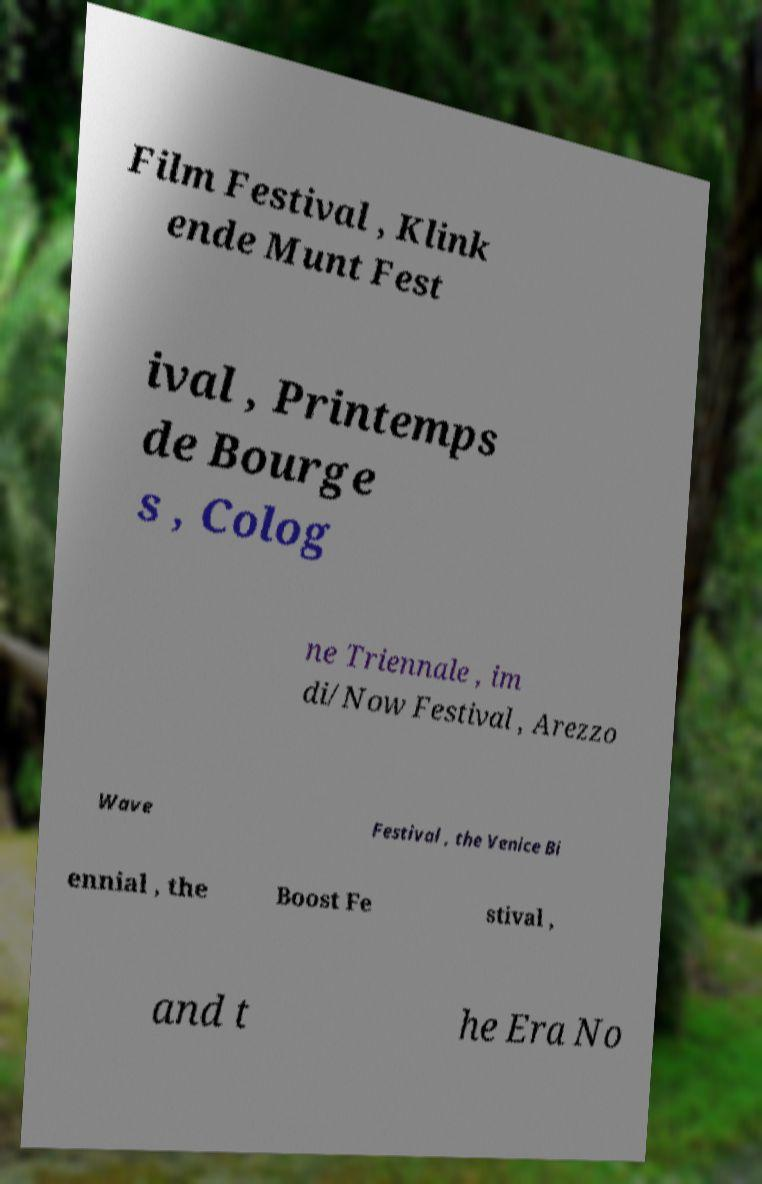Can you accurately transcribe the text from the provided image for me? Film Festival , Klink ende Munt Fest ival , Printemps de Bourge s , Colog ne Triennale , im di/Now Festival , Arezzo Wave Festival , the Venice Bi ennial , the Boost Fe stival , and t he Era No 